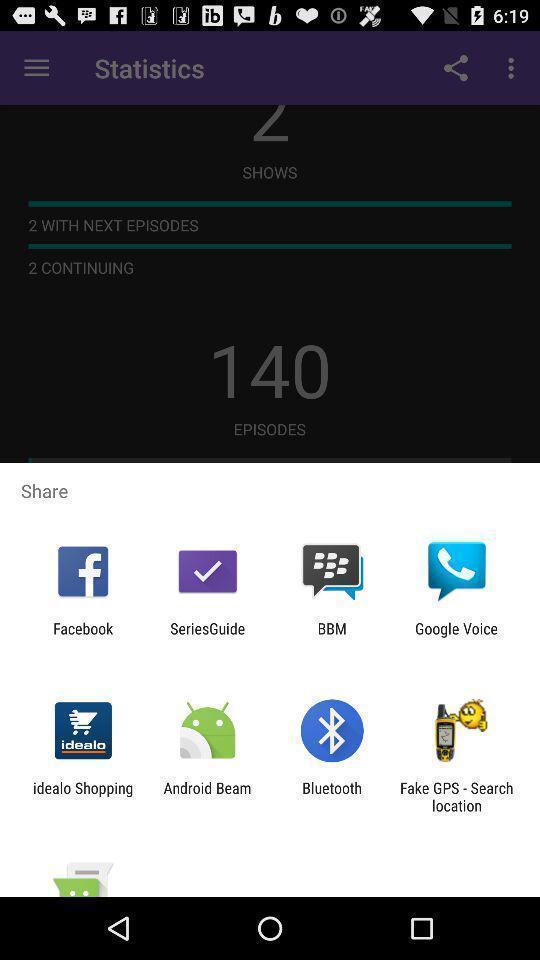What details can you identify in this image? Pop-up to share using different apps. 